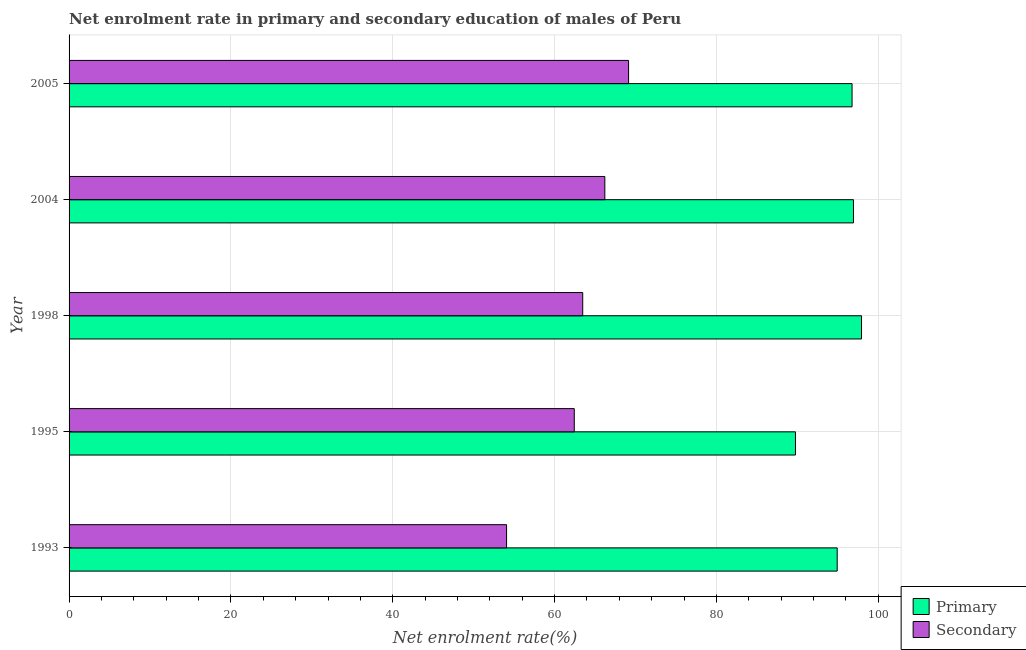Are the number of bars per tick equal to the number of legend labels?
Keep it short and to the point. Yes. Are the number of bars on each tick of the Y-axis equal?
Provide a short and direct response. Yes. How many bars are there on the 3rd tick from the top?
Offer a very short reply. 2. How many bars are there on the 3rd tick from the bottom?
Your answer should be very brief. 2. What is the label of the 5th group of bars from the top?
Your answer should be very brief. 1993. What is the enrollment rate in secondary education in 1998?
Provide a succinct answer. 63.48. Across all years, what is the maximum enrollment rate in secondary education?
Your answer should be very brief. 69.15. Across all years, what is the minimum enrollment rate in secondary education?
Your answer should be compact. 54.07. What is the total enrollment rate in primary education in the graph?
Offer a very short reply. 476.34. What is the difference between the enrollment rate in primary education in 1993 and that in 2004?
Offer a very short reply. -2.01. What is the difference between the enrollment rate in secondary education in 1998 and the enrollment rate in primary education in 2004?
Offer a very short reply. -33.46. What is the average enrollment rate in secondary education per year?
Provide a short and direct response. 63.07. In the year 1993, what is the difference between the enrollment rate in primary education and enrollment rate in secondary education?
Make the answer very short. 40.86. What is the ratio of the enrollment rate in secondary education in 1998 to that in 2005?
Offer a terse response. 0.92. What is the difference between the highest and the lowest enrollment rate in secondary education?
Offer a very short reply. 15.08. In how many years, is the enrollment rate in primary education greater than the average enrollment rate in primary education taken over all years?
Ensure brevity in your answer.  3. Is the sum of the enrollment rate in secondary education in 1995 and 2005 greater than the maximum enrollment rate in primary education across all years?
Offer a terse response. Yes. What does the 2nd bar from the top in 2004 represents?
Keep it short and to the point. Primary. What does the 1st bar from the bottom in 1993 represents?
Give a very brief answer. Primary. How many bars are there?
Provide a short and direct response. 10. Are all the bars in the graph horizontal?
Provide a succinct answer. Yes. What is the difference between two consecutive major ticks on the X-axis?
Give a very brief answer. 20. Does the graph contain any zero values?
Keep it short and to the point. No. Where does the legend appear in the graph?
Keep it short and to the point. Bottom right. How are the legend labels stacked?
Your answer should be compact. Vertical. What is the title of the graph?
Keep it short and to the point. Net enrolment rate in primary and secondary education of males of Peru. What is the label or title of the X-axis?
Make the answer very short. Net enrolment rate(%). What is the Net enrolment rate(%) of Primary in 1993?
Your answer should be compact. 94.93. What is the Net enrolment rate(%) of Secondary in 1993?
Your answer should be very brief. 54.07. What is the Net enrolment rate(%) of Primary in 1995?
Make the answer very short. 89.77. What is the Net enrolment rate(%) in Secondary in 1995?
Offer a terse response. 62.44. What is the Net enrolment rate(%) of Primary in 1998?
Offer a terse response. 97.93. What is the Net enrolment rate(%) in Secondary in 1998?
Offer a very short reply. 63.48. What is the Net enrolment rate(%) in Primary in 2004?
Ensure brevity in your answer.  96.94. What is the Net enrolment rate(%) of Secondary in 2004?
Keep it short and to the point. 66.21. What is the Net enrolment rate(%) of Primary in 2005?
Give a very brief answer. 96.77. What is the Net enrolment rate(%) of Secondary in 2005?
Your answer should be compact. 69.15. Across all years, what is the maximum Net enrolment rate(%) of Primary?
Your answer should be compact. 97.93. Across all years, what is the maximum Net enrolment rate(%) of Secondary?
Make the answer very short. 69.15. Across all years, what is the minimum Net enrolment rate(%) of Primary?
Your answer should be compact. 89.77. Across all years, what is the minimum Net enrolment rate(%) in Secondary?
Your answer should be very brief. 54.07. What is the total Net enrolment rate(%) in Primary in the graph?
Provide a succinct answer. 476.34. What is the total Net enrolment rate(%) of Secondary in the graph?
Ensure brevity in your answer.  315.34. What is the difference between the Net enrolment rate(%) of Primary in 1993 and that in 1995?
Provide a short and direct response. 5.16. What is the difference between the Net enrolment rate(%) of Secondary in 1993 and that in 1995?
Your answer should be compact. -8.37. What is the difference between the Net enrolment rate(%) of Primary in 1993 and that in 1998?
Your answer should be very brief. -3.01. What is the difference between the Net enrolment rate(%) in Secondary in 1993 and that in 1998?
Provide a short and direct response. -9.41. What is the difference between the Net enrolment rate(%) of Primary in 1993 and that in 2004?
Ensure brevity in your answer.  -2.01. What is the difference between the Net enrolment rate(%) in Secondary in 1993 and that in 2004?
Your answer should be very brief. -12.14. What is the difference between the Net enrolment rate(%) in Primary in 1993 and that in 2005?
Your answer should be very brief. -1.84. What is the difference between the Net enrolment rate(%) of Secondary in 1993 and that in 2005?
Ensure brevity in your answer.  -15.08. What is the difference between the Net enrolment rate(%) in Primary in 1995 and that in 1998?
Keep it short and to the point. -8.16. What is the difference between the Net enrolment rate(%) in Secondary in 1995 and that in 1998?
Keep it short and to the point. -1.04. What is the difference between the Net enrolment rate(%) of Primary in 1995 and that in 2004?
Make the answer very short. -7.17. What is the difference between the Net enrolment rate(%) of Secondary in 1995 and that in 2004?
Keep it short and to the point. -3.78. What is the difference between the Net enrolment rate(%) in Primary in 1995 and that in 2005?
Make the answer very short. -6.99. What is the difference between the Net enrolment rate(%) in Secondary in 1995 and that in 2005?
Give a very brief answer. -6.71. What is the difference between the Net enrolment rate(%) of Primary in 1998 and that in 2004?
Offer a terse response. 0.99. What is the difference between the Net enrolment rate(%) in Secondary in 1998 and that in 2004?
Your response must be concise. -2.73. What is the difference between the Net enrolment rate(%) in Primary in 1998 and that in 2005?
Offer a very short reply. 1.17. What is the difference between the Net enrolment rate(%) of Secondary in 1998 and that in 2005?
Offer a very short reply. -5.67. What is the difference between the Net enrolment rate(%) of Primary in 2004 and that in 2005?
Your answer should be compact. 0.17. What is the difference between the Net enrolment rate(%) in Secondary in 2004 and that in 2005?
Offer a terse response. -2.94. What is the difference between the Net enrolment rate(%) in Primary in 1993 and the Net enrolment rate(%) in Secondary in 1995?
Your answer should be very brief. 32.49. What is the difference between the Net enrolment rate(%) of Primary in 1993 and the Net enrolment rate(%) of Secondary in 1998?
Give a very brief answer. 31.45. What is the difference between the Net enrolment rate(%) in Primary in 1993 and the Net enrolment rate(%) in Secondary in 2004?
Make the answer very short. 28.72. What is the difference between the Net enrolment rate(%) of Primary in 1993 and the Net enrolment rate(%) of Secondary in 2005?
Make the answer very short. 25.78. What is the difference between the Net enrolment rate(%) in Primary in 1995 and the Net enrolment rate(%) in Secondary in 1998?
Your answer should be very brief. 26.29. What is the difference between the Net enrolment rate(%) in Primary in 1995 and the Net enrolment rate(%) in Secondary in 2004?
Your response must be concise. 23.56. What is the difference between the Net enrolment rate(%) in Primary in 1995 and the Net enrolment rate(%) in Secondary in 2005?
Your answer should be compact. 20.63. What is the difference between the Net enrolment rate(%) of Primary in 1998 and the Net enrolment rate(%) of Secondary in 2004?
Give a very brief answer. 31.72. What is the difference between the Net enrolment rate(%) in Primary in 1998 and the Net enrolment rate(%) in Secondary in 2005?
Your answer should be compact. 28.79. What is the difference between the Net enrolment rate(%) of Primary in 2004 and the Net enrolment rate(%) of Secondary in 2005?
Provide a succinct answer. 27.79. What is the average Net enrolment rate(%) in Primary per year?
Give a very brief answer. 95.27. What is the average Net enrolment rate(%) of Secondary per year?
Provide a succinct answer. 63.07. In the year 1993, what is the difference between the Net enrolment rate(%) of Primary and Net enrolment rate(%) of Secondary?
Provide a succinct answer. 40.86. In the year 1995, what is the difference between the Net enrolment rate(%) in Primary and Net enrolment rate(%) in Secondary?
Ensure brevity in your answer.  27.34. In the year 1998, what is the difference between the Net enrolment rate(%) in Primary and Net enrolment rate(%) in Secondary?
Keep it short and to the point. 34.45. In the year 2004, what is the difference between the Net enrolment rate(%) of Primary and Net enrolment rate(%) of Secondary?
Your response must be concise. 30.73. In the year 2005, what is the difference between the Net enrolment rate(%) in Primary and Net enrolment rate(%) in Secondary?
Provide a short and direct response. 27.62. What is the ratio of the Net enrolment rate(%) of Primary in 1993 to that in 1995?
Ensure brevity in your answer.  1.06. What is the ratio of the Net enrolment rate(%) in Secondary in 1993 to that in 1995?
Your answer should be very brief. 0.87. What is the ratio of the Net enrolment rate(%) in Primary in 1993 to that in 1998?
Your response must be concise. 0.97. What is the ratio of the Net enrolment rate(%) in Secondary in 1993 to that in 1998?
Keep it short and to the point. 0.85. What is the ratio of the Net enrolment rate(%) in Primary in 1993 to that in 2004?
Provide a succinct answer. 0.98. What is the ratio of the Net enrolment rate(%) of Secondary in 1993 to that in 2004?
Your answer should be compact. 0.82. What is the ratio of the Net enrolment rate(%) of Primary in 1993 to that in 2005?
Provide a short and direct response. 0.98. What is the ratio of the Net enrolment rate(%) of Secondary in 1993 to that in 2005?
Ensure brevity in your answer.  0.78. What is the ratio of the Net enrolment rate(%) in Secondary in 1995 to that in 1998?
Offer a terse response. 0.98. What is the ratio of the Net enrolment rate(%) in Primary in 1995 to that in 2004?
Make the answer very short. 0.93. What is the ratio of the Net enrolment rate(%) in Secondary in 1995 to that in 2004?
Ensure brevity in your answer.  0.94. What is the ratio of the Net enrolment rate(%) in Primary in 1995 to that in 2005?
Your answer should be very brief. 0.93. What is the ratio of the Net enrolment rate(%) of Secondary in 1995 to that in 2005?
Keep it short and to the point. 0.9. What is the ratio of the Net enrolment rate(%) in Primary in 1998 to that in 2004?
Provide a succinct answer. 1.01. What is the ratio of the Net enrolment rate(%) in Secondary in 1998 to that in 2004?
Ensure brevity in your answer.  0.96. What is the ratio of the Net enrolment rate(%) of Primary in 1998 to that in 2005?
Your answer should be very brief. 1.01. What is the ratio of the Net enrolment rate(%) in Secondary in 1998 to that in 2005?
Make the answer very short. 0.92. What is the ratio of the Net enrolment rate(%) of Primary in 2004 to that in 2005?
Make the answer very short. 1. What is the ratio of the Net enrolment rate(%) in Secondary in 2004 to that in 2005?
Give a very brief answer. 0.96. What is the difference between the highest and the second highest Net enrolment rate(%) in Primary?
Give a very brief answer. 0.99. What is the difference between the highest and the second highest Net enrolment rate(%) in Secondary?
Your answer should be very brief. 2.94. What is the difference between the highest and the lowest Net enrolment rate(%) in Primary?
Provide a succinct answer. 8.16. What is the difference between the highest and the lowest Net enrolment rate(%) of Secondary?
Keep it short and to the point. 15.08. 